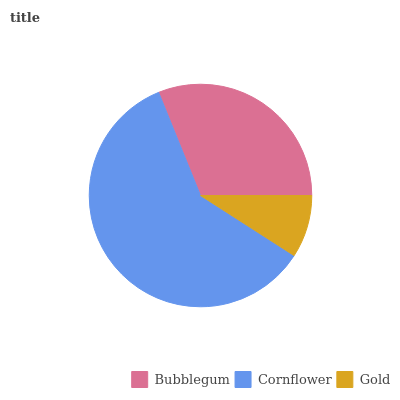Is Gold the minimum?
Answer yes or no. Yes. Is Cornflower the maximum?
Answer yes or no. Yes. Is Cornflower the minimum?
Answer yes or no. No. Is Gold the maximum?
Answer yes or no. No. Is Cornflower greater than Gold?
Answer yes or no. Yes. Is Gold less than Cornflower?
Answer yes or no. Yes. Is Gold greater than Cornflower?
Answer yes or no. No. Is Cornflower less than Gold?
Answer yes or no. No. Is Bubblegum the high median?
Answer yes or no. Yes. Is Bubblegum the low median?
Answer yes or no. Yes. Is Gold the high median?
Answer yes or no. No. Is Cornflower the low median?
Answer yes or no. No. 